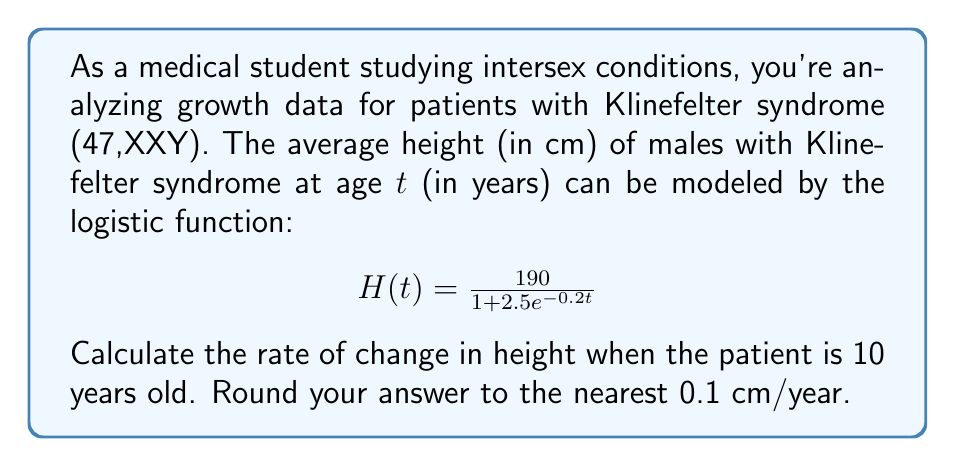Can you answer this question? To solve this problem, we need to find the derivative of the given function and evaluate it at $t = 10$. Here's a step-by-step approach:

1) The given function is:
   $$H(t) = \frac{190}{1 + 2.5e^{-0.2t}}$$

2) To find the rate of change, we need to differentiate $H(t)$ with respect to $t$. Let's use the quotient rule:
   $$H'(t) = \frac{(1 + 2.5e^{-0.2t}) \cdot 0 - 190 \cdot (-2.5e^{-0.2t} \cdot -0.2)}{(1 + 2.5e^{-0.2t})^2}$$

3) Simplify:
   $$H'(t) = \frac{190 \cdot 0.5e^{-0.2t} \cdot 0.2}{(1 + 2.5e^{-0.2t})^2}$$
   $$H'(t) = \frac{19e^{-0.2t}}{(1 + 2.5e^{-0.2t})^2}$$

4) Now, we need to evaluate this at $t = 10$:
   $$H'(10) = \frac{19e^{-0.2(10)}}{(1 + 2.5e^{-0.2(10)})^2}$$

5) Calculate:
   $$H'(10) = \frac{19e^{-2}}{(1 + 2.5e^{-2})^2} \approx 4.76$$

6) Rounding to the nearest 0.1:
   $$H'(10) \approx 4.8$$

Therefore, the rate of change in height when the patient is 10 years old is approximately 4.8 cm/year.
Answer: 4.8 cm/year 